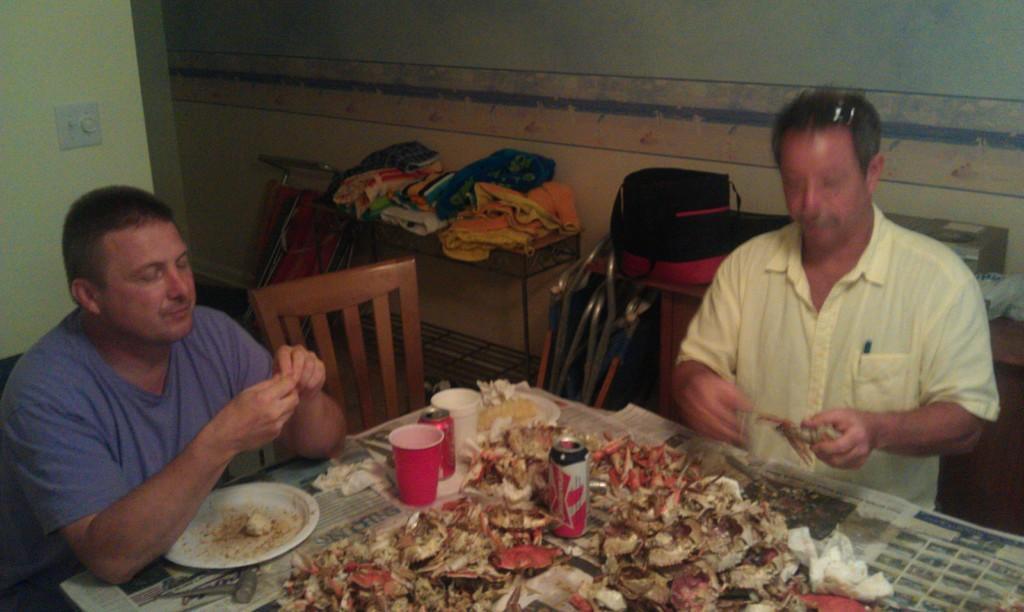Describe this image in one or two sentences. In the foreground of this image, there are two persons one in yellow color and another in blue. They are sitting near a table on which tins, cups, and garbage is placed on it. In the background, there is wall, folding chairs, clothes on table and a switch board. 